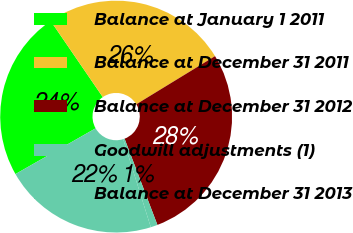<chart> <loc_0><loc_0><loc_500><loc_500><pie_chart><fcel>Balance at January 1 2011<fcel>Balance at December 31 2011<fcel>Balance at December 31 2012<fcel>Goodwill adjustments (1)<fcel>Balance at December 31 2013<nl><fcel>23.7%<fcel>25.82%<fcel>27.94%<fcel>0.96%<fcel>21.58%<nl></chart> 